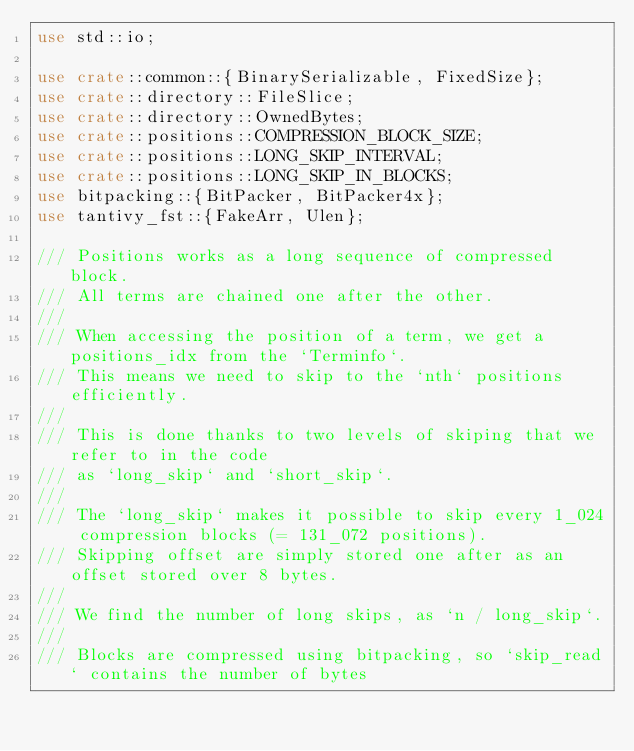Convert code to text. <code><loc_0><loc_0><loc_500><loc_500><_Rust_>use std::io;

use crate::common::{BinarySerializable, FixedSize};
use crate::directory::FileSlice;
use crate::directory::OwnedBytes;
use crate::positions::COMPRESSION_BLOCK_SIZE;
use crate::positions::LONG_SKIP_INTERVAL;
use crate::positions::LONG_SKIP_IN_BLOCKS;
use bitpacking::{BitPacker, BitPacker4x};
use tantivy_fst::{FakeArr, Ulen};

/// Positions works as a long sequence of compressed block.
/// All terms are chained one after the other.
///
/// When accessing the position of a term, we get a positions_idx from the `Terminfo`.
/// This means we need to skip to the `nth` positions efficiently.
///
/// This is done thanks to two levels of skiping that we refer to in the code
/// as `long_skip` and `short_skip`.
///
/// The `long_skip` makes it possible to skip every 1_024 compression blocks (= 131_072 positions).
/// Skipping offset are simply stored one after as an offset stored over 8 bytes.
///
/// We find the number of long skips, as `n / long_skip`.
///
/// Blocks are compressed using bitpacking, so `skip_read` contains the number of bytes</code> 